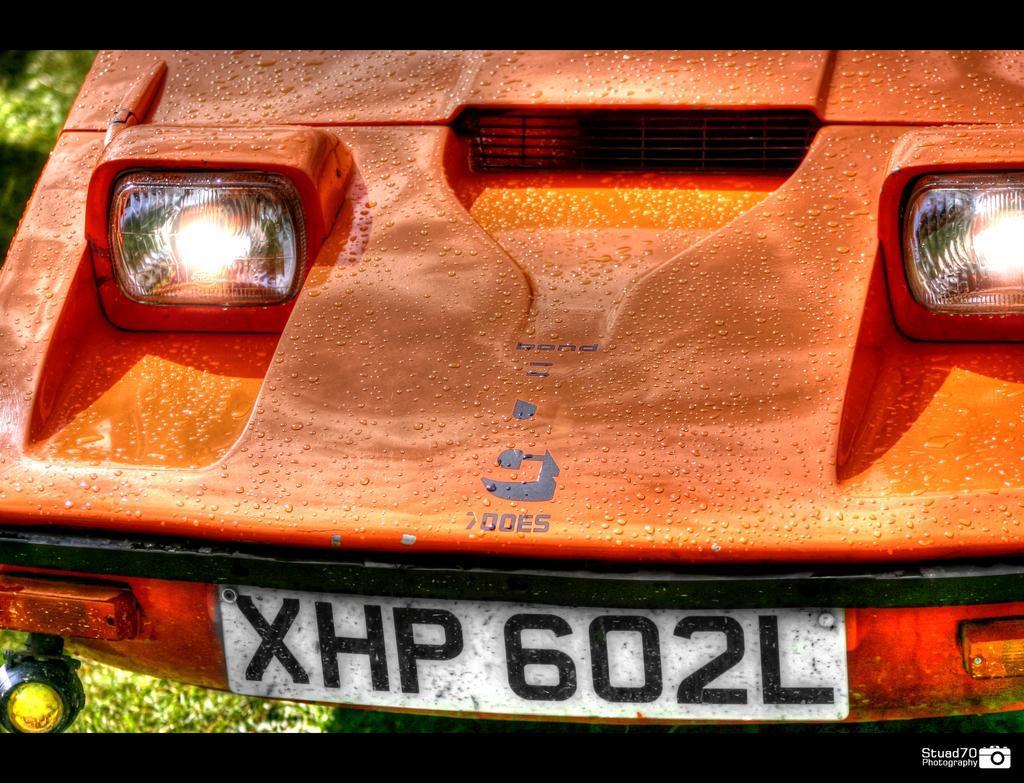Can you describe this image briefly? This is a zoomed in picture. In the center we can see the front part of the vehicle and we can see the number plate and the headlights. In the background we can see the plants. 